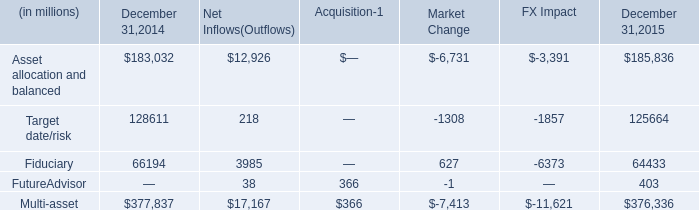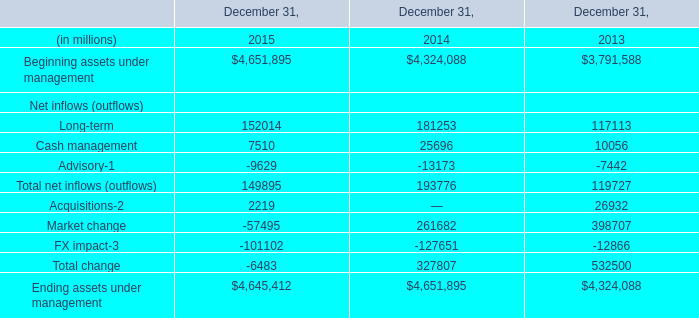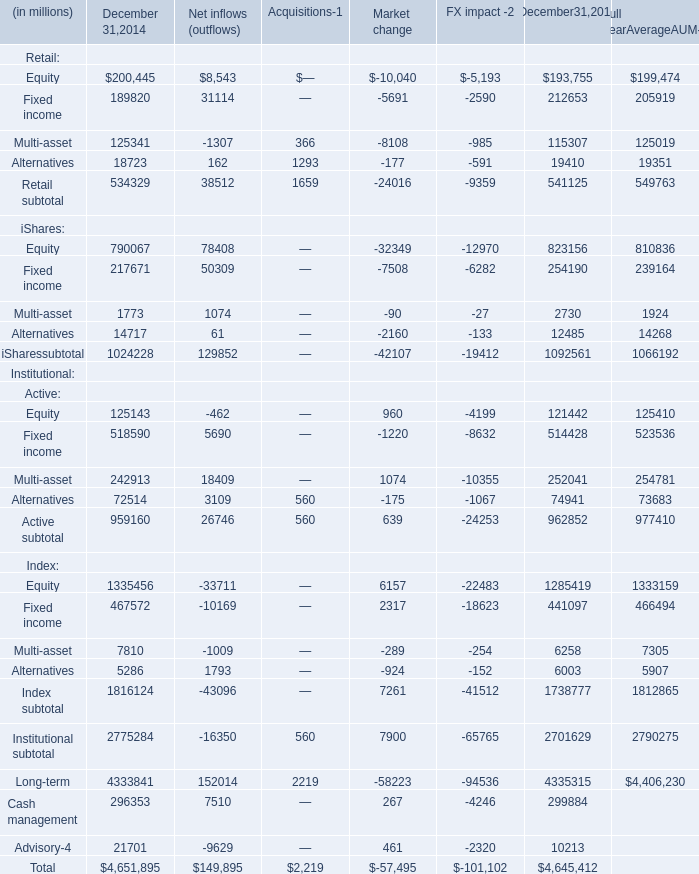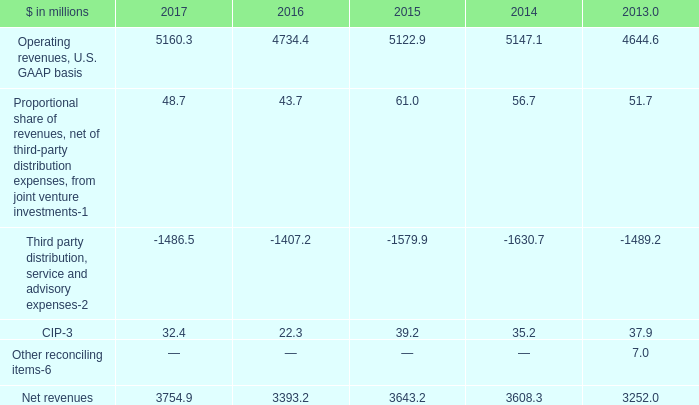What is the average value of Acquisitions in Table 1 and Net revenues in Table 3 in 2015? (in million) 
Computations: ((2219 + 3643.2) / 2)
Answer: 2931.1. 